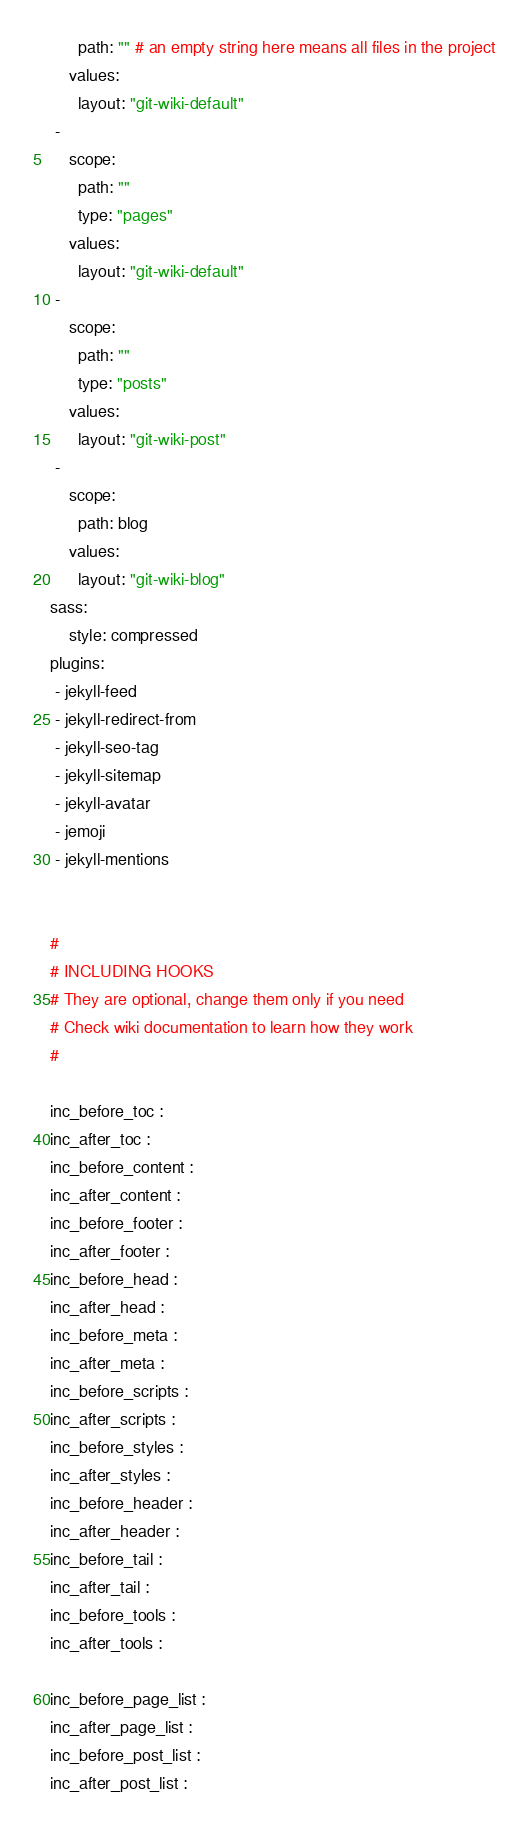<code> <loc_0><loc_0><loc_500><loc_500><_YAML_>      path: "" # an empty string here means all files in the project
    values:
      layout: "git-wiki-default"
 -
    scope:
      path: ""
      type: "pages"
    values:
      layout: "git-wiki-default"
 -
    scope:
      path: ""
      type: "posts"
    values:
      layout: "git-wiki-post"
 -
    scope:
      path: blog
    values:
      layout: "git-wiki-blog"
sass:
    style: compressed
plugins:
 - jekyll-feed
 - jekyll-redirect-from
 - jekyll-seo-tag
 - jekyll-sitemap
 - jekyll-avatar
 - jemoji
 - jekyll-mentions


#
# INCLUDING HOOKS
# They are optional, change them only if you need
# Check wiki documentation to learn how they work
#

inc_before_toc : 
inc_after_toc : 
inc_before_content : 
inc_after_content : 
inc_before_footer : 
inc_after_footer : 
inc_before_head : 
inc_after_head : 
inc_before_meta : 
inc_after_meta : 
inc_before_scripts : 
inc_after_scripts : 
inc_before_styles : 
inc_after_styles : 
inc_before_header : 
inc_after_header : 
inc_before_tail : 
inc_after_tail : 
inc_before_tools : 
inc_after_tools : 

inc_before_page_list :
inc_after_page_list :
inc_before_post_list :
inc_after_post_list :
</code> 